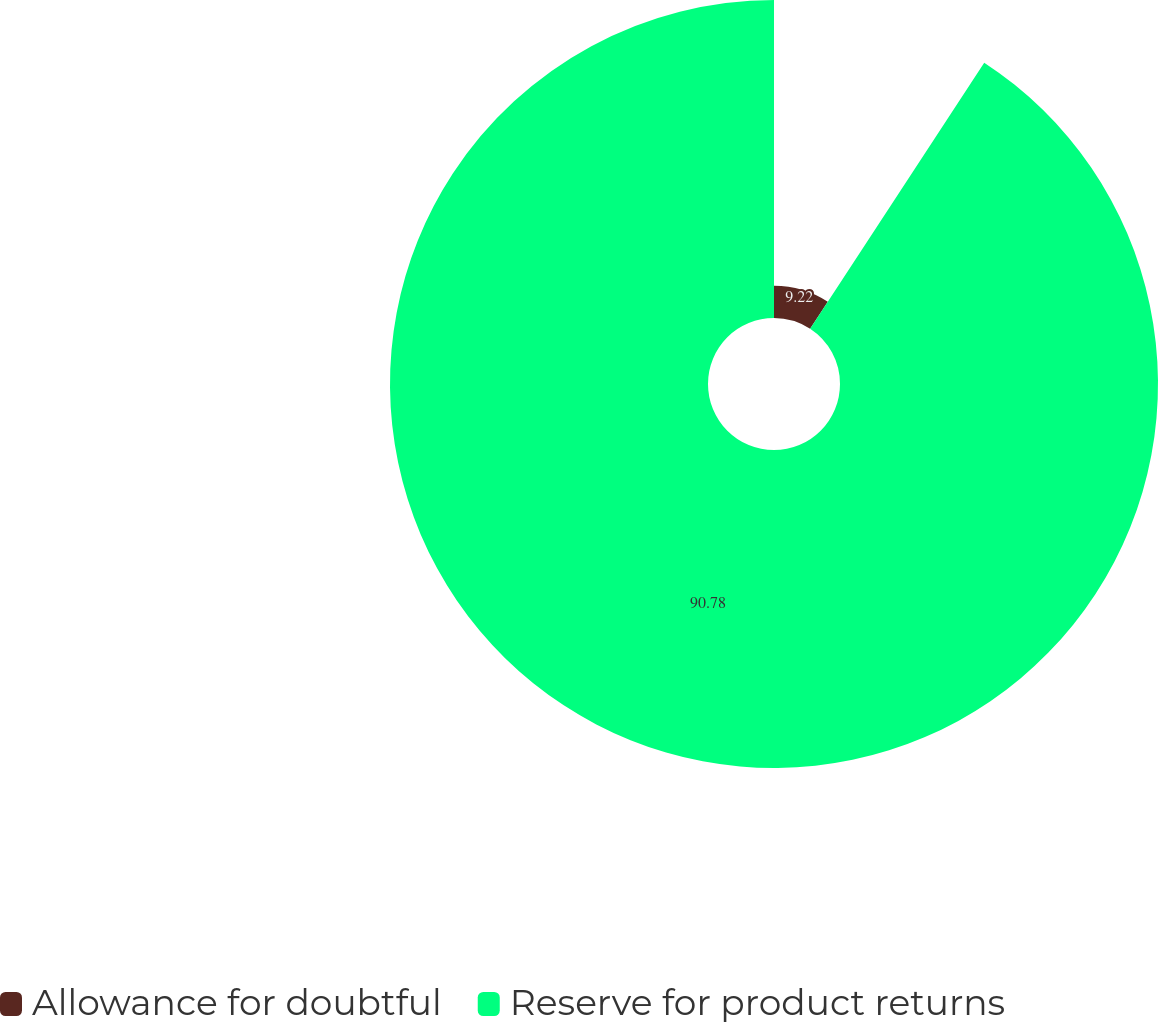<chart> <loc_0><loc_0><loc_500><loc_500><pie_chart><fcel>Allowance for doubtful<fcel>Reserve for product returns<nl><fcel>9.22%<fcel>90.78%<nl></chart> 